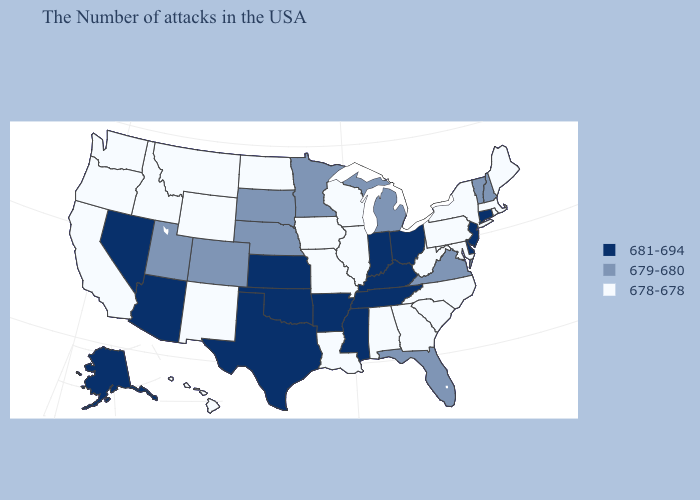Which states hav the highest value in the MidWest?
Write a very short answer. Ohio, Indiana, Kansas. What is the value of Louisiana?
Keep it brief. 678-678. What is the lowest value in the USA?
Answer briefly. 678-678. Does New York have the lowest value in the USA?
Concise answer only. Yes. What is the value of Indiana?
Write a very short answer. 681-694. What is the lowest value in states that border Connecticut?
Quick response, please. 678-678. How many symbols are there in the legend?
Be succinct. 3. What is the value of Tennessee?
Write a very short answer. 681-694. Among the states that border Kansas , which have the highest value?
Be succinct. Oklahoma. What is the value of Oregon?
Be succinct. 678-678. Does Kentucky have the same value as Wyoming?
Quick response, please. No. What is the value of Arkansas?
Keep it brief. 681-694. What is the value of Alabama?
Quick response, please. 678-678. What is the value of Michigan?
Keep it brief. 679-680. Name the states that have a value in the range 681-694?
Keep it brief. Connecticut, New Jersey, Delaware, Ohio, Kentucky, Indiana, Tennessee, Mississippi, Arkansas, Kansas, Oklahoma, Texas, Arizona, Nevada, Alaska. 